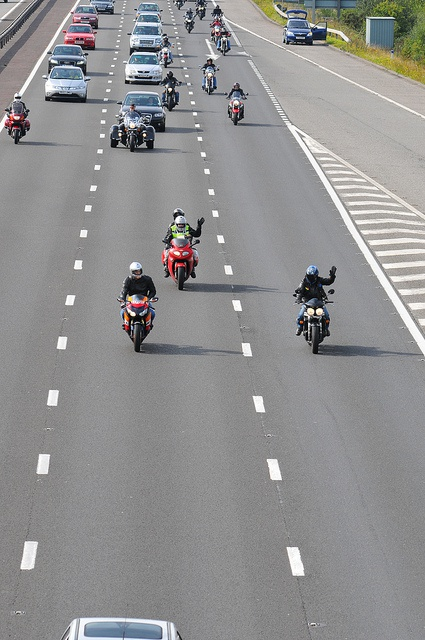Describe the objects in this image and their specific colors. I can see car in darkgray, white, and gray tones, motorcycle in darkgray, black, gray, and lightgray tones, people in darkgray and gray tones, car in darkgray, lavender, black, and gray tones, and motorcycle in darkgray, black, gray, and brown tones in this image. 